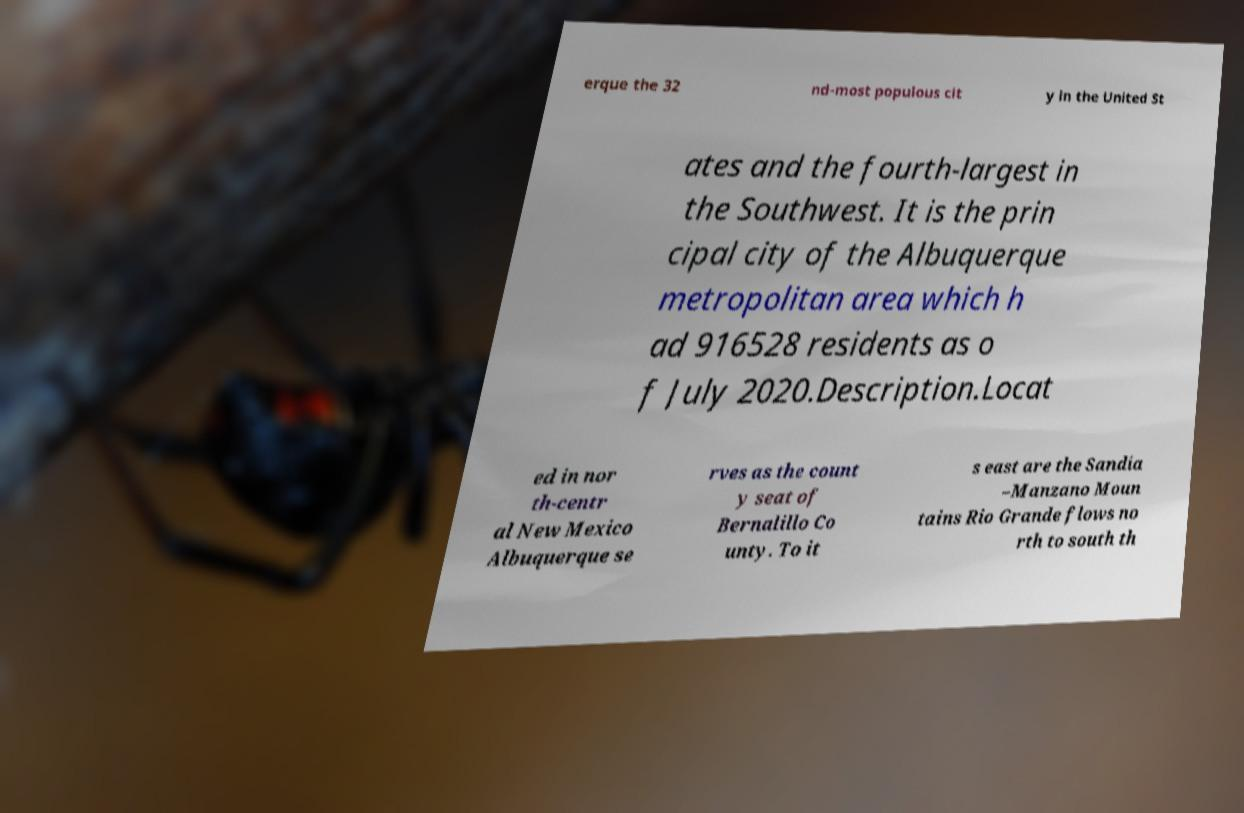Can you read and provide the text displayed in the image?This photo seems to have some interesting text. Can you extract and type it out for me? erque the 32 nd-most populous cit y in the United St ates and the fourth-largest in the Southwest. It is the prin cipal city of the Albuquerque metropolitan area which h ad 916528 residents as o f July 2020.Description.Locat ed in nor th-centr al New Mexico Albuquerque se rves as the count y seat of Bernalillo Co unty. To it s east are the Sandia –Manzano Moun tains Rio Grande flows no rth to south th 